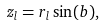Convert formula to latex. <formula><loc_0><loc_0><loc_500><loc_500>z _ { l } = r _ { l } \sin ( b ) , \\</formula> 